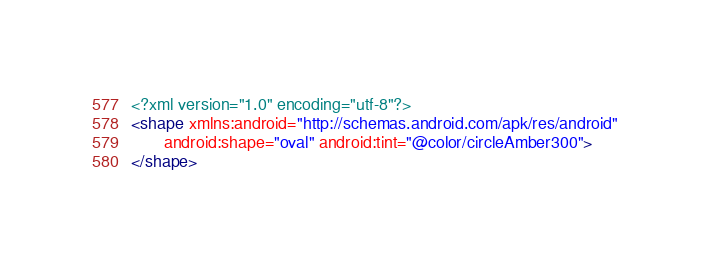Convert code to text. <code><loc_0><loc_0><loc_500><loc_500><_XML_><?xml version="1.0" encoding="utf-8"?>
<shape xmlns:android="http://schemas.android.com/apk/res/android"
       android:shape="oval" android:tint="@color/circleAmber300">
</shape></code> 